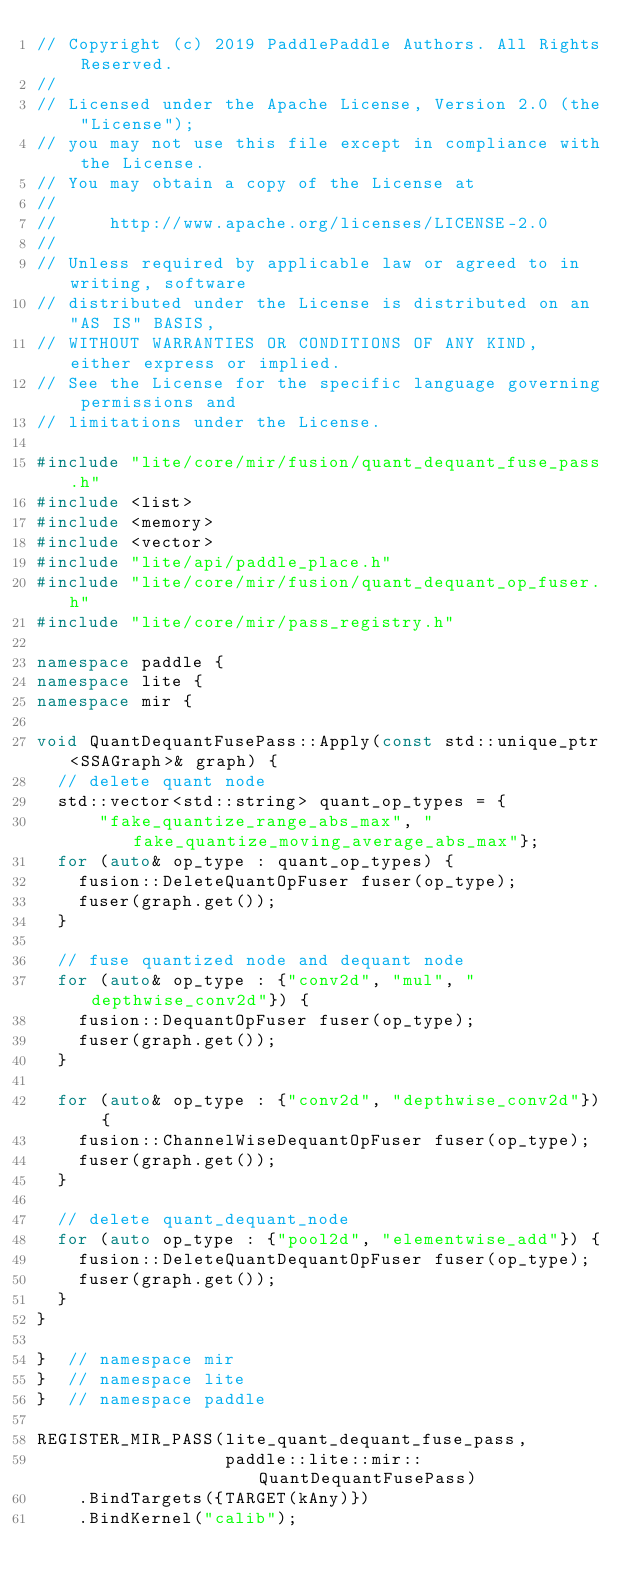Convert code to text. <code><loc_0><loc_0><loc_500><loc_500><_C++_>// Copyright (c) 2019 PaddlePaddle Authors. All Rights Reserved.
//
// Licensed under the Apache License, Version 2.0 (the "License");
// you may not use this file except in compliance with the License.
// You may obtain a copy of the License at
//
//     http://www.apache.org/licenses/LICENSE-2.0
//
// Unless required by applicable law or agreed to in writing, software
// distributed under the License is distributed on an "AS IS" BASIS,
// WITHOUT WARRANTIES OR CONDITIONS OF ANY KIND, either express or implied.
// See the License for the specific language governing permissions and
// limitations under the License.

#include "lite/core/mir/fusion/quant_dequant_fuse_pass.h"
#include <list>
#include <memory>
#include <vector>
#include "lite/api/paddle_place.h"
#include "lite/core/mir/fusion/quant_dequant_op_fuser.h"
#include "lite/core/mir/pass_registry.h"

namespace paddle {
namespace lite {
namespace mir {

void QuantDequantFusePass::Apply(const std::unique_ptr<SSAGraph>& graph) {
  // delete quant node
  std::vector<std::string> quant_op_types = {
      "fake_quantize_range_abs_max", "fake_quantize_moving_average_abs_max"};
  for (auto& op_type : quant_op_types) {
    fusion::DeleteQuantOpFuser fuser(op_type);
    fuser(graph.get());
  }

  // fuse quantized node and dequant node
  for (auto& op_type : {"conv2d", "mul", "depthwise_conv2d"}) {
    fusion::DequantOpFuser fuser(op_type);
    fuser(graph.get());
  }

  for (auto& op_type : {"conv2d", "depthwise_conv2d"}) {
    fusion::ChannelWiseDequantOpFuser fuser(op_type);
    fuser(graph.get());
  }

  // delete quant_dequant_node
  for (auto op_type : {"pool2d", "elementwise_add"}) {
    fusion::DeleteQuantDequantOpFuser fuser(op_type);
    fuser(graph.get());
  }
}

}  // namespace mir
}  // namespace lite
}  // namespace paddle

REGISTER_MIR_PASS(lite_quant_dequant_fuse_pass,
                  paddle::lite::mir::QuantDequantFusePass)
    .BindTargets({TARGET(kAny)})
    .BindKernel("calib");
</code> 